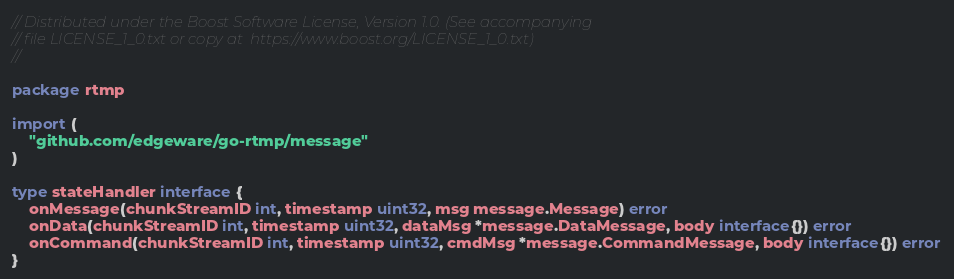Convert code to text. <code><loc_0><loc_0><loc_500><loc_500><_Go_>// Distributed under the Boost Software License, Version 1.0. (See accompanying
// file LICENSE_1_0.txt or copy at  https://www.boost.org/LICENSE_1_0.txt)
//

package rtmp

import (
	"github.com/edgeware/go-rtmp/message"
)

type stateHandler interface {
	onMessage(chunkStreamID int, timestamp uint32, msg message.Message) error
	onData(chunkStreamID int, timestamp uint32, dataMsg *message.DataMessage, body interface{}) error
	onCommand(chunkStreamID int, timestamp uint32, cmdMsg *message.CommandMessage, body interface{}) error
}
</code> 